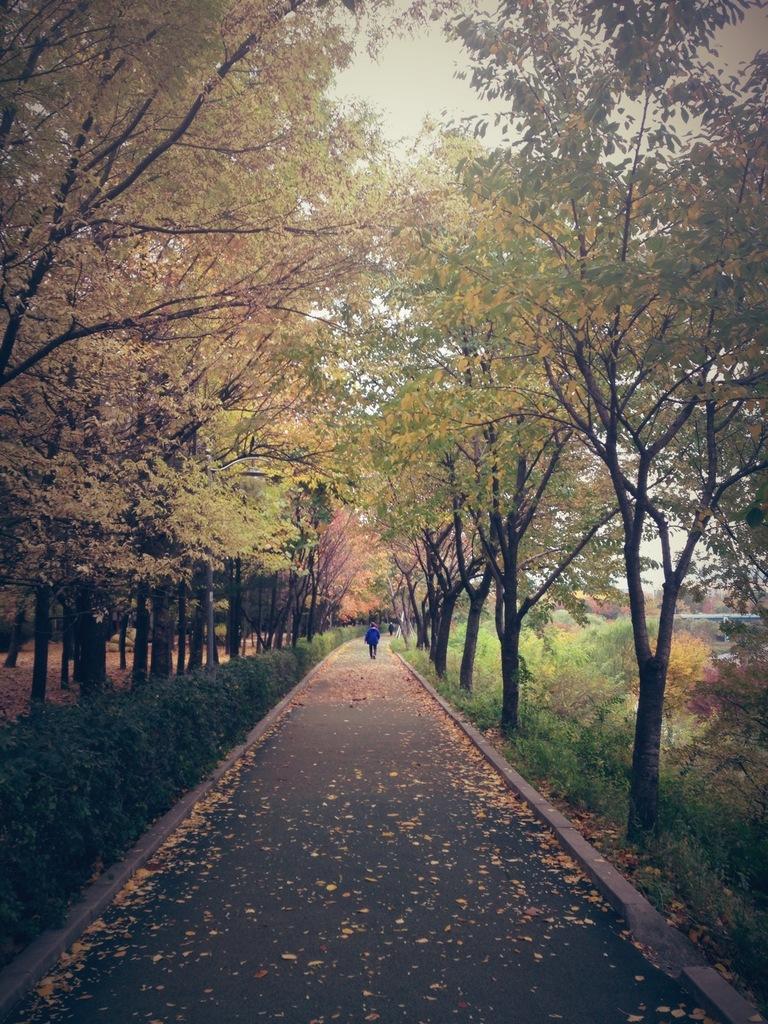Could you give a brief overview of what you see in this image? In this image there are trees. We can see a walkway and there are people. There are plants. In the background three is sky. 